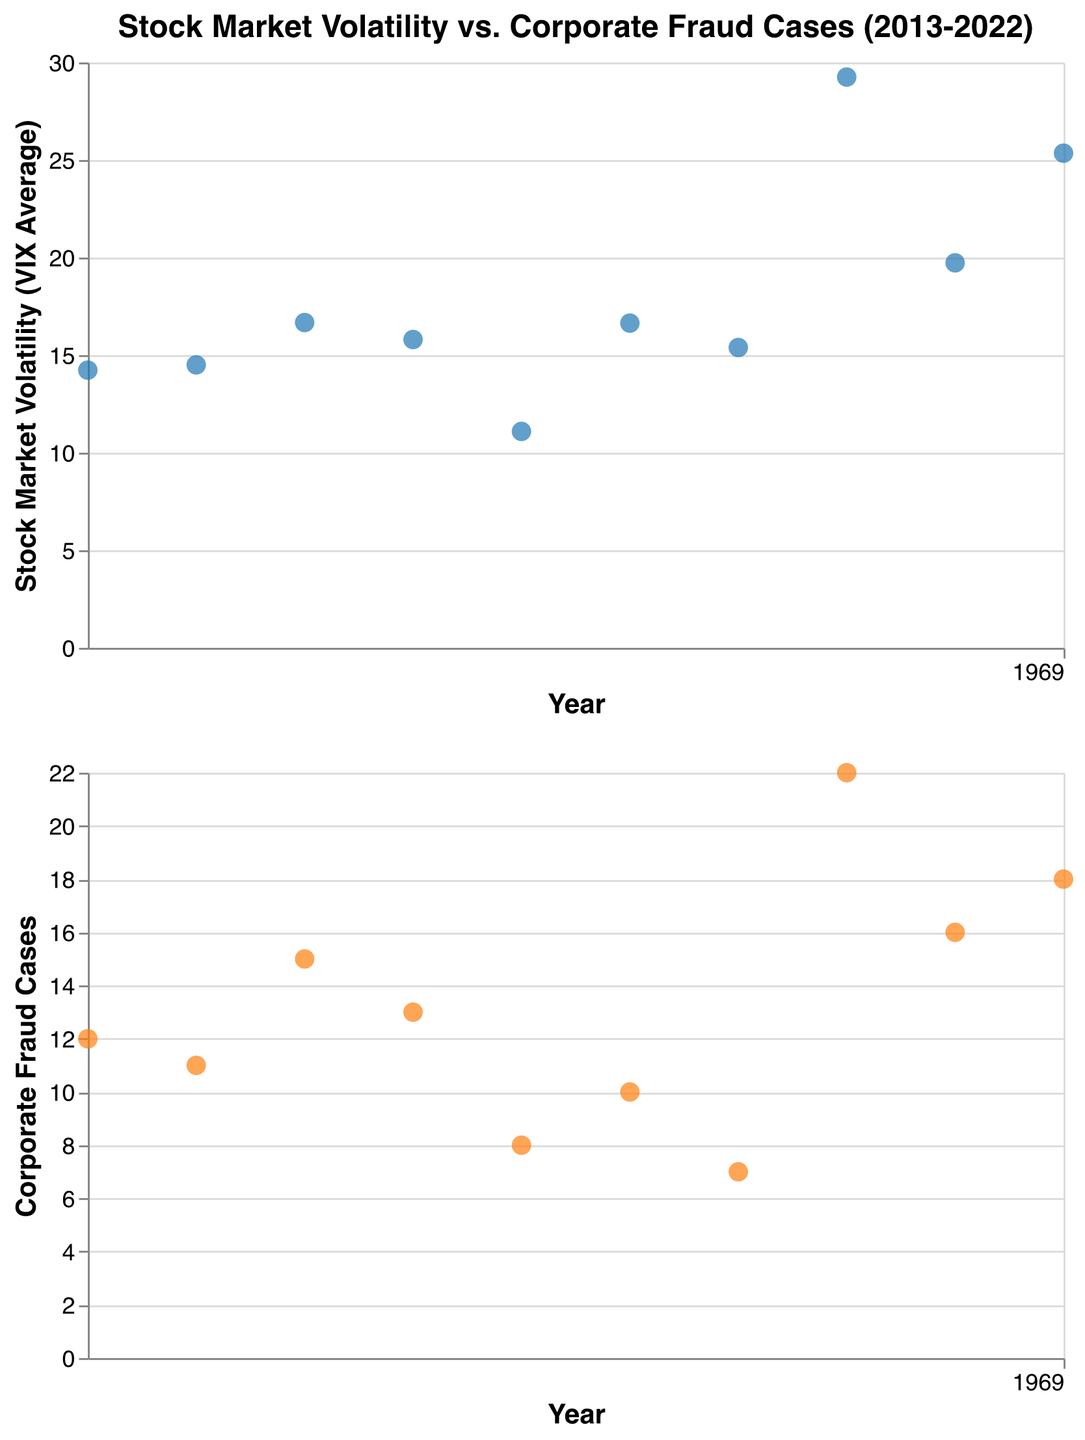What is the title of the subplot figure? The title is located at the top of the figure and clearly states what the figure is about. The title helps the viewer understand the overarching theme of the data presented in the subplot.
Answer: Stock Market Volatility vs. Corporate Fraud Cases (2013-2022) How many data points are there in each subplot? Count the number of points present in each subplot. Here, each data point corresponds to a year from 2013 to 2022.
Answer: 10 What year had the highest stock market volatility? Look for the data point that is highest on the Y-axis in the first subplot. The Y-axis represents stock market volatility measured by the VIX average.
Answer: 2020 Which year had the lowest number of corporate fraud cases? Locate the data point that is lowest on the Y-axis in the second subplot. This Y-axis represents the number of corporate fraud cases.
Answer: 2019 In which years did both stock market volatility and corporate fraud cases increase compared to the previous year? Compare the data point positions sequentially. Identify the years when both subplots show an upward trend from the previous year.
Answer: 2015, 2020 What's the average stock market volatility throughout the decade? Sum the VIX Average values for all years and divide by the number of years (10). (14.23+14.50+16.67+15.80+11.09+16.64+15.39+29.25+19.73+25.35)/10 = 17.665
Answer: 17.67 What's the difference in corporate fraud cases between the year with the highest cases and the year with the lowest cases? Identify the highest (22 in 2020) and lowest (7 in 2019) points on the Y-axis of the second subplot. Subtract the lowest from the highest (22 - 7).
Answer: 15 How did the stock market volatility and corporate fraud cases change from 2019 to 2020? Observe the difference in both the VIX Average and the number of fraud cases from 2019 to 2020. 2019: 15.39 VIX, 7 cases; 2020: 29.25 VIX, 22 cases. Both increased.
Answer: Increased Which subplot color represents stock market volatility? Identify the color used for the data points in the first subplot.
Answer: Blue What is the trend in stock market volatility in the first subplot over the last decade? Assess the general direction of the data points in the first subplot from 2013 to 2022. The trend can be determined by observing if data points mostly move upward or downward over time.
Answer: Generally increasing 